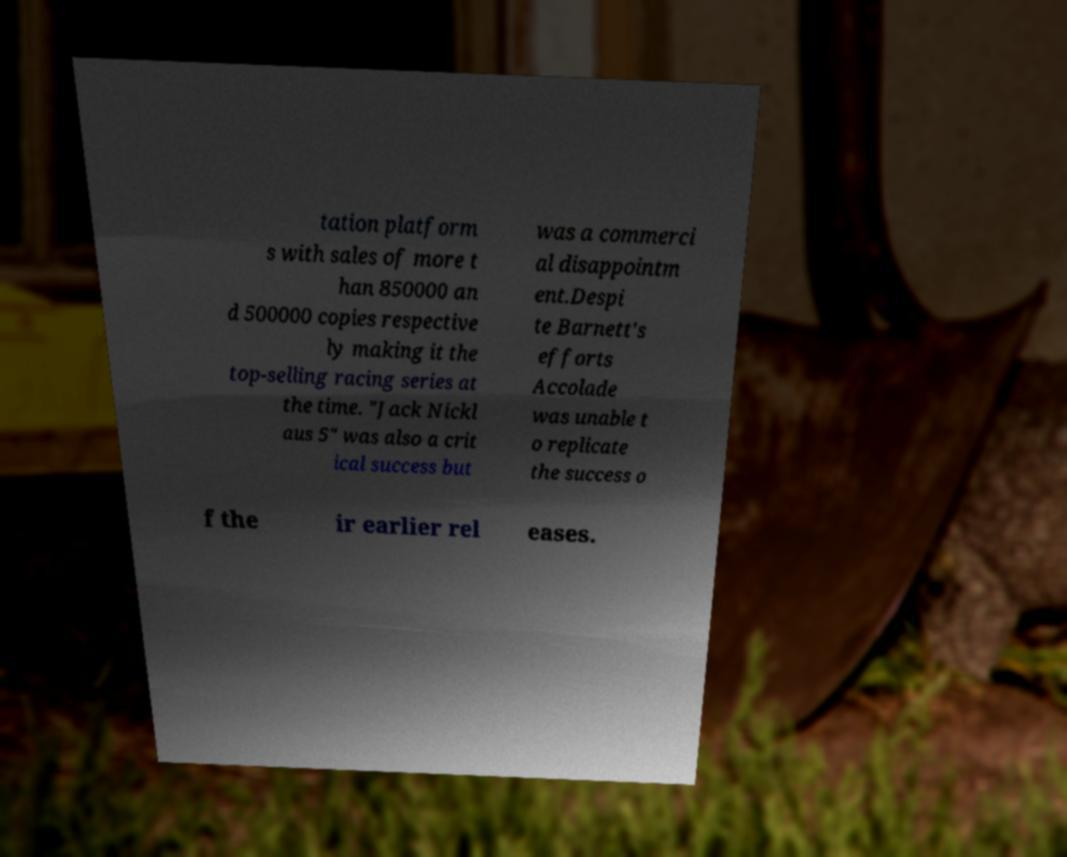I need the written content from this picture converted into text. Can you do that? tation platform s with sales of more t han 850000 an d 500000 copies respective ly making it the top-selling racing series at the time. "Jack Nickl aus 5" was also a crit ical success but was a commerci al disappointm ent.Despi te Barnett's efforts Accolade was unable t o replicate the success o f the ir earlier rel eases. 